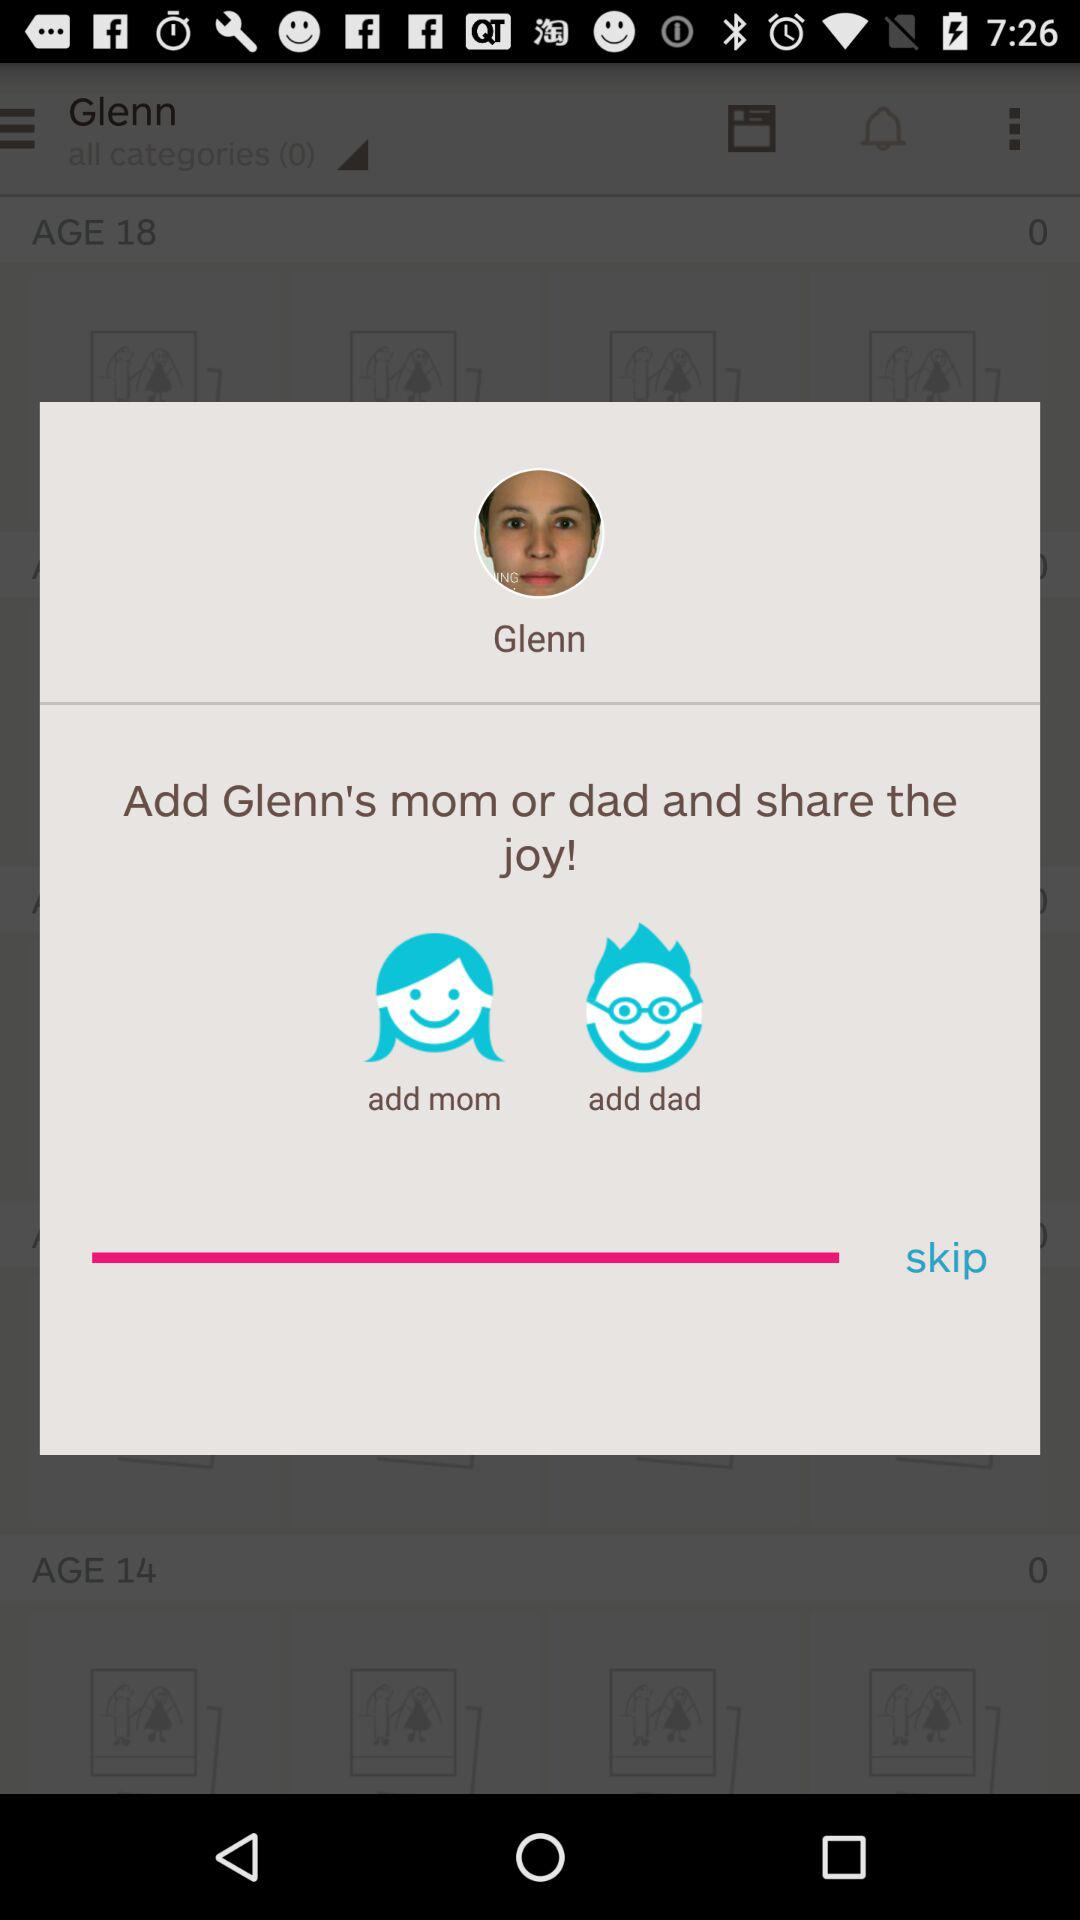What is the name of the user? The name of the user is Glenn. 